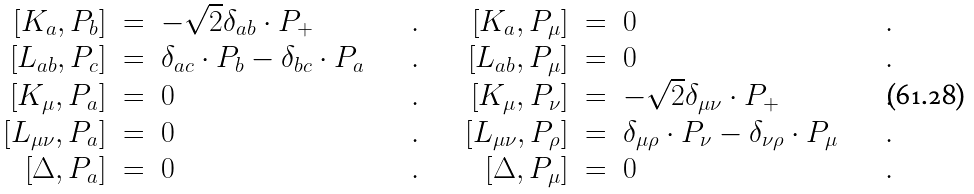Convert formula to latex. <formula><loc_0><loc_0><loc_500><loc_500>\begin{array} { r c l c r c l c } \left [ K _ { a } , P _ { b } \right ] & = & - \sqrt { 2 } \delta _ { a b } \cdot P _ { + } & \quad . \quad & \left [ K _ { a } , P _ { \mu } \right ] & = & 0 & \quad . \\ \left [ L _ { a b } , P _ { c } \right ] & = & \delta _ { a c } \cdot P _ { b } - \delta _ { b c } \cdot P _ { a } & \quad . \quad & \left [ L _ { a b } , P _ { \mu } \right ] & = & 0 & \quad . \\ \left [ K _ { \mu } , P _ { a } \right ] & = & 0 & \quad . \quad & \left [ K _ { \mu } , P _ { \nu } \right ] & = & - \sqrt { 2 } \delta _ { \mu \nu } \cdot P _ { + } & \quad . \\ \left [ L _ { \mu \nu } , P _ { a } \right ] & = & 0 & \quad . \quad & \left [ L _ { \mu \nu } , P _ { \rho } \right ] & = & \delta _ { \mu \rho } \cdot P _ { \nu } - \delta _ { \nu \rho } \cdot P _ { \mu } & \quad . \\ \left [ \Delta , P _ { a } \right ] & = & 0 & \quad . \quad & \left [ \Delta , P _ { \mu } \right ] & = & 0 & \quad . \end{array}</formula> 